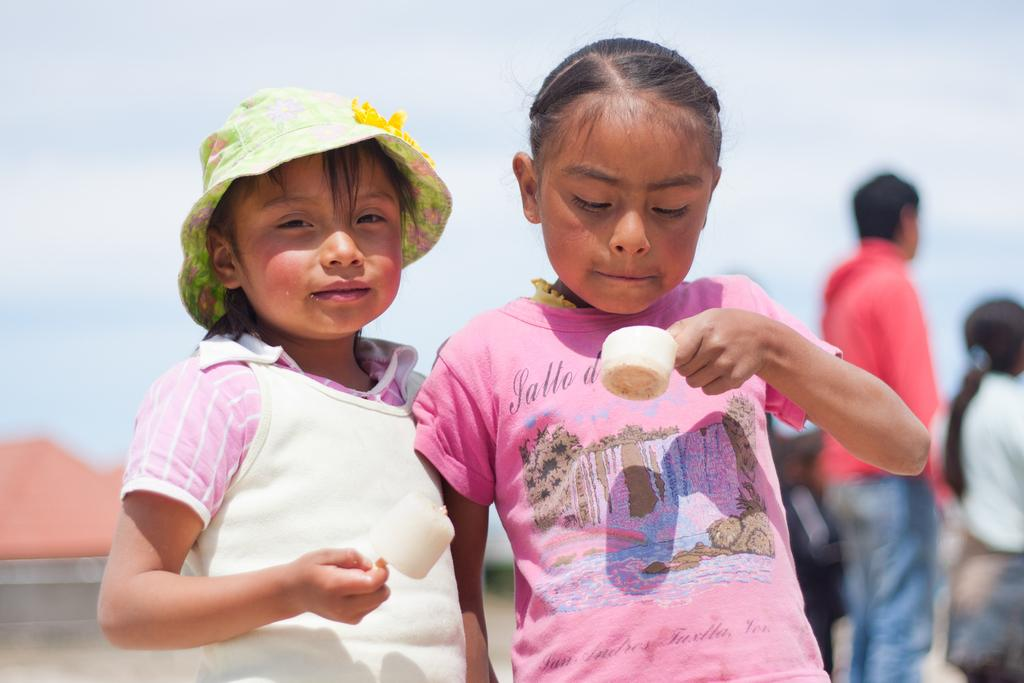How many children are present in the image? There are two children in the image. What are the children doing in the image? The children are holding an object. What is the effect of the quiet afternoon on the children in the image? The provided facts do not mention the time of day or the atmosphere, so it is not possible to determine the effect of a quiet afternoon on the children in the image. 